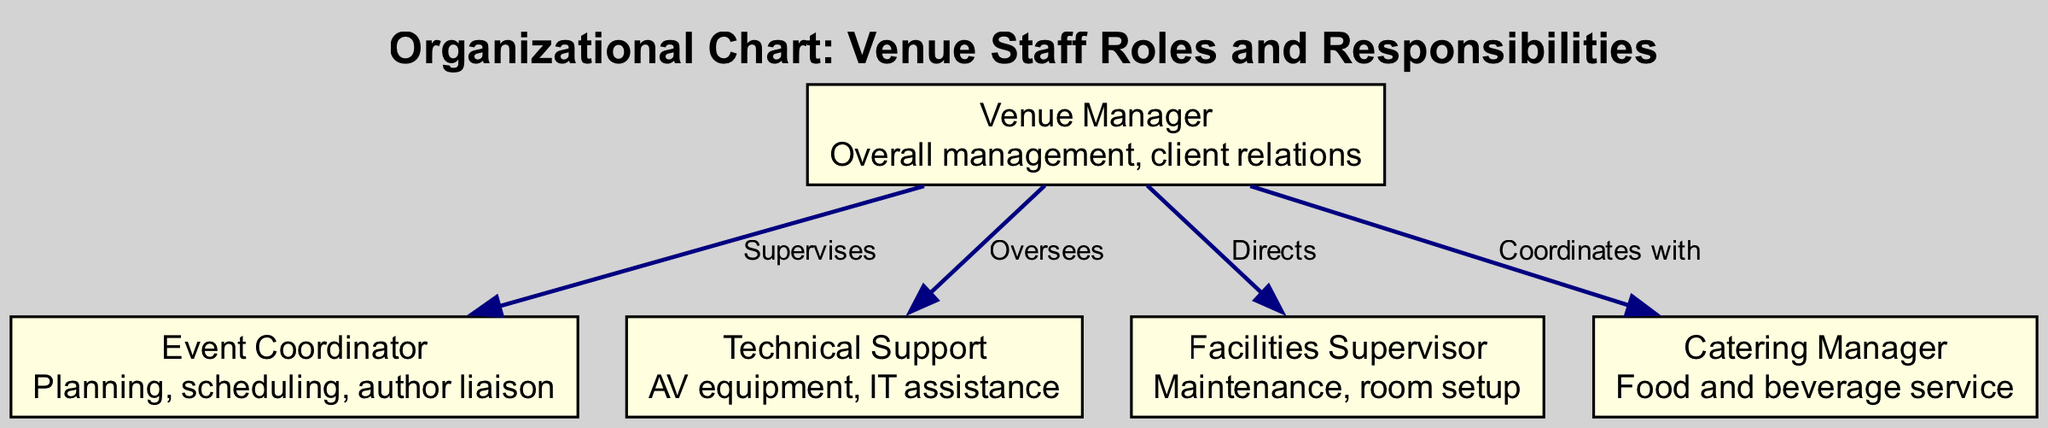What is the title of the diagram? The title is stated at the top of the diagram and clearly indicates the focus of the diagram, which is "Organizational Chart: Venue Staff Roles and Responsibilities."
Answer: Organizational Chart: Venue Staff Roles and Responsibilities How many nodes are there in the diagram? Counting the individual roles listed in the nodes section, we find that there are 5 distinct roles (Venue Manager, Event Coordinator, Technical Support, Facilities Supervisor, Catering Manager).
Answer: 5 Who supervises the Event Coordinator? According to the edges, the "Venue Manager" supervises the "Event Coordinator" as depicted with a clear direction indicated in the diagram from the Venue Manager to the Event Coordinator.
Answer: Venue Manager What is the responsibility of the Facilities Supervisor? The responsibility is detailed within the node for the Facilities Supervisor, stating it is related to "Maintenance, room setup."
Answer: Maintenance, room setup What does the Technical Support role oversee? From the edge connections, the "Technical Support" role is overseen by the "Venue Manager," which indicates its position in the hierarchy.
Answer: Venue Manager How many edges are present in the diagram? By counting the connections (edges) between the nodes that define the relationships or responsibilities, we see there are a total of 4 edges.
Answer: 4 What is the relationship between the Venue Manager and the Catering Manager? The diagram specifies that the Venue Manager "Coordinates with" the Catering Manager, indicating a collaborative relationship as described in the edges.
Answer: Coordinates with Which role is responsible for AV equipment? The responsibility of AV equipment falls under the Technical Support role, as explicitly stated in the description within that node.
Answer: Technical Support What is the primary role of the Event Coordinator? The primary responsibilities of the Event Coordinator, as stated in the node, include "Planning, scheduling, author liaison," indicating its focus on event logistics and communication.
Answer: Planning, scheduling, author liaison 